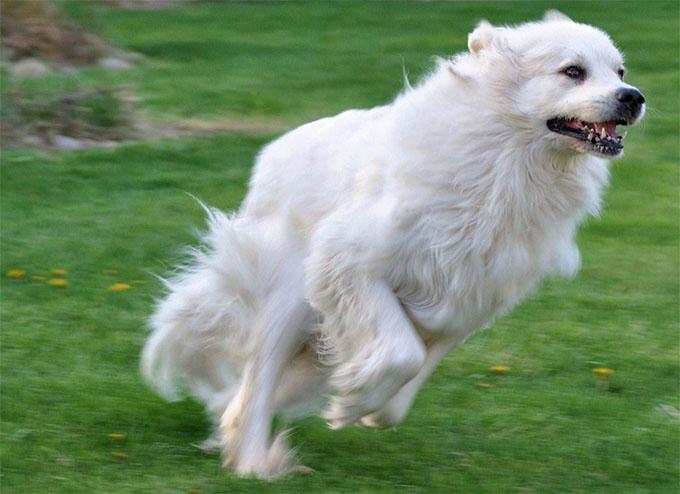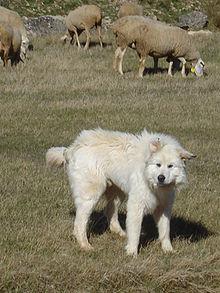The first image is the image on the left, the second image is the image on the right. Assess this claim about the two images: "Both images have a fluffy dog with one or more sheep.". Correct or not? Answer yes or no. No. 